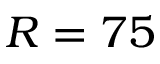<formula> <loc_0><loc_0><loc_500><loc_500>R = 7 5</formula> 